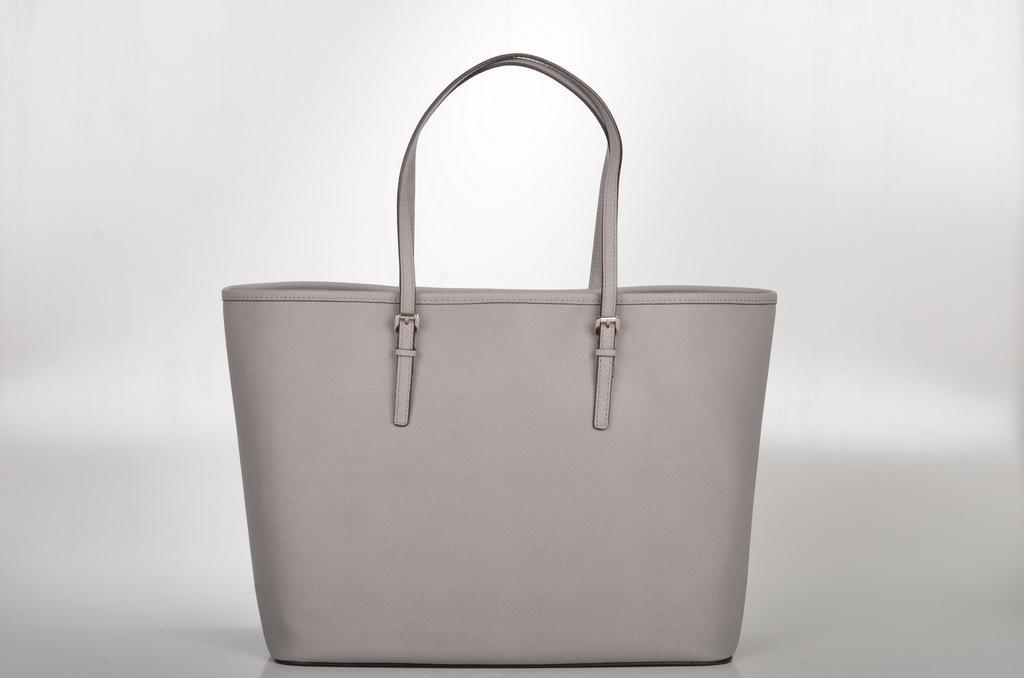How would you summarize this image in a sentence or two? This picture describes about a handbag. 